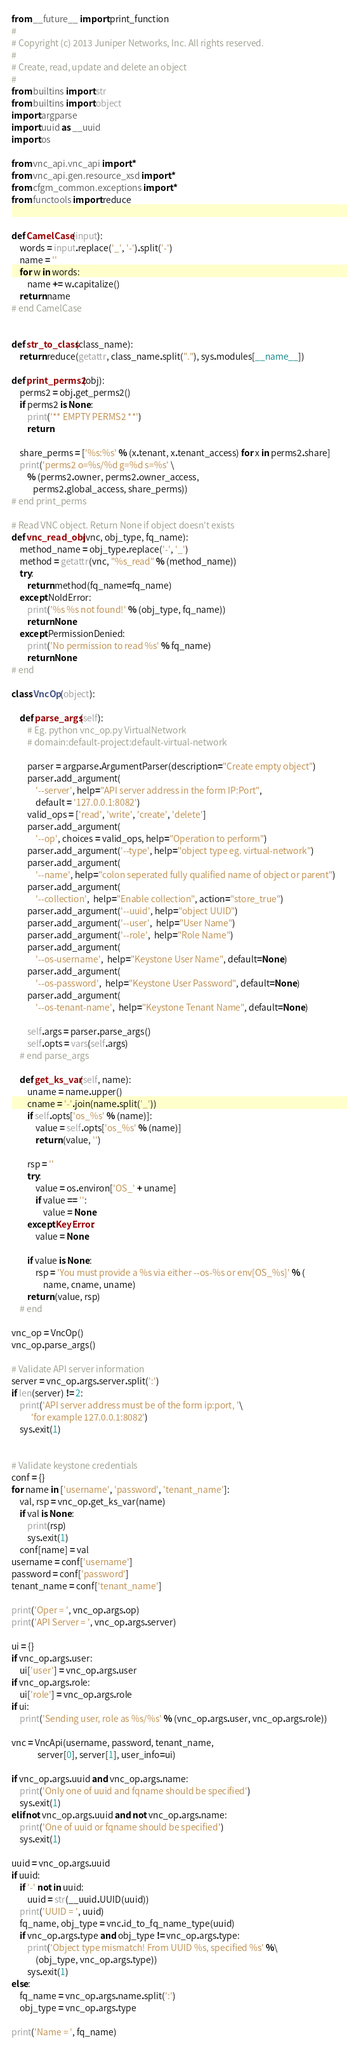Convert code to text. <code><loc_0><loc_0><loc_500><loc_500><_Python_>from __future__ import print_function
#
# Copyright (c) 2013 Juniper Networks, Inc. All rights reserved.
#
# Create, read, update and delete an object
#
from builtins import str
from builtins import object
import argparse
import uuid as __uuid
import os

from vnc_api.vnc_api import *
from vnc_api.gen.resource_xsd import *
from cfgm_common.exceptions import *
from functools import reduce


def CamelCase(input):
    words = input.replace('_', '-').split('-')
    name = ''
    for w in words:
        name += w.capitalize()
    return name
# end CamelCase


def str_to_class(class_name):
    return reduce(getattr, class_name.split("."), sys.modules[__name__])

def print_perms2(obj):
    perms2 = obj.get_perms2()
    if perms2 is None:
        print('** EMPTY PERMS2 **')
        return

    share_perms = ['%s:%s' % (x.tenant, x.tenant_access) for x in perms2.share]
    print('perms2 o=%s/%d g=%d s=%s' \
        % (perms2.owner, perms2.owner_access,
           perms2.global_access, share_perms))
# end print_perms

# Read VNC object. Return None if object doesn't exists
def vnc_read_obj(vnc, obj_type, fq_name):
    method_name = obj_type.replace('-', '_')
    method = getattr(vnc, "%s_read" % (method_name))
    try:
        return method(fq_name=fq_name)
    except NoIdError:
        print('%s %s not found!' % (obj_type, fq_name))
        return None
    except PermissionDenied:
        print('No permission to read %s' % fq_name)
        return None
# end

class VncOp(object):

    def parse_args(self):
        # Eg. python vnc_op.py VirtualNetwork
        # domain:default-project:default-virtual-network

        parser = argparse.ArgumentParser(description="Create empty object")
        parser.add_argument(
            '--server', help="API server address in the form IP:Port",
            default = '127.0.0.1:8082')
        valid_ops = ['read', 'write', 'create', 'delete']
        parser.add_argument(
            '--op', choices = valid_ops, help="Operation to perform")
        parser.add_argument('--type', help="object type eg. virtual-network")
        parser.add_argument(
            '--name', help="colon seperated fully qualified name of object or parent")
        parser.add_argument(
            '--collection',  help="Enable collection", action="store_true")
        parser.add_argument('--uuid', help="object UUID")
        parser.add_argument('--user',  help="User Name")
        parser.add_argument('--role',  help="Role Name")
        parser.add_argument(
            '--os-username',  help="Keystone User Name", default=None)
        parser.add_argument(
            '--os-password',  help="Keystone User Password", default=None)
        parser.add_argument(
            '--os-tenant-name',  help="Keystone Tenant Name", default=None)

        self.args = parser.parse_args()
        self.opts = vars(self.args)
    # end parse_args

    def get_ks_var(self, name):
        uname = name.upper()
        cname = '-'.join(name.split('_'))
        if self.opts['os_%s' % (name)]:
            value = self.opts['os_%s' % (name)]
            return (value, '')

        rsp = ''
        try:
            value = os.environ['OS_' + uname]
            if value == '':
                value = None
        except KeyError:
            value = None

        if value is None:
            rsp = 'You must provide a %s via either --os-%s or env[OS_%s]' % (
                name, cname, uname)
        return (value, rsp)
    # end

vnc_op = VncOp()
vnc_op.parse_args()

# Validate API server information
server = vnc_op.args.server.split(':')
if len(server) != 2:
    print('API server address must be of the form ip:port, '\
          'for example 127.0.0.1:8082')
    sys.exit(1)


# Validate keystone credentials
conf = {}
for name in ['username', 'password', 'tenant_name']:
    val, rsp = vnc_op.get_ks_var(name)
    if val is None:
        print(rsp)
        sys.exit(1)
    conf[name] = val
username = conf['username']
password = conf['password']
tenant_name = conf['tenant_name']

print('Oper = ', vnc_op.args.op)
print('API Server = ', vnc_op.args.server)

ui = {}
if vnc_op.args.user:
    ui['user'] = vnc_op.args.user
if vnc_op.args.role:
    ui['role'] = vnc_op.args.role
if ui:
    print('Sending user, role as %s/%s' % (vnc_op.args.user, vnc_op.args.role))

vnc = VncApi(username, password, tenant_name,
             server[0], server[1], user_info=ui)

if vnc_op.args.uuid and vnc_op.args.name:
    print('Only one of uuid and fqname should be specified')
    sys.exit(1)
elif not vnc_op.args.uuid and not vnc_op.args.name:
    print('One of uuid or fqname should be specified')
    sys.exit(1)

uuid = vnc_op.args.uuid
if uuid:
    if '-' not in uuid:
        uuid = str(__uuid.UUID(uuid))
    print('UUID = ', uuid)
    fq_name, obj_type = vnc.id_to_fq_name_type(uuid)
    if vnc_op.args.type and obj_type != vnc_op.args.type:
        print('Object type mismatch! From UUID %s, specified %s' %\
            (obj_type, vnc_op.args.type))
        sys.exit(1)
else:
    fq_name = vnc_op.args.name.split(':')
    obj_type = vnc_op.args.type

print('Name = ', fq_name)</code> 